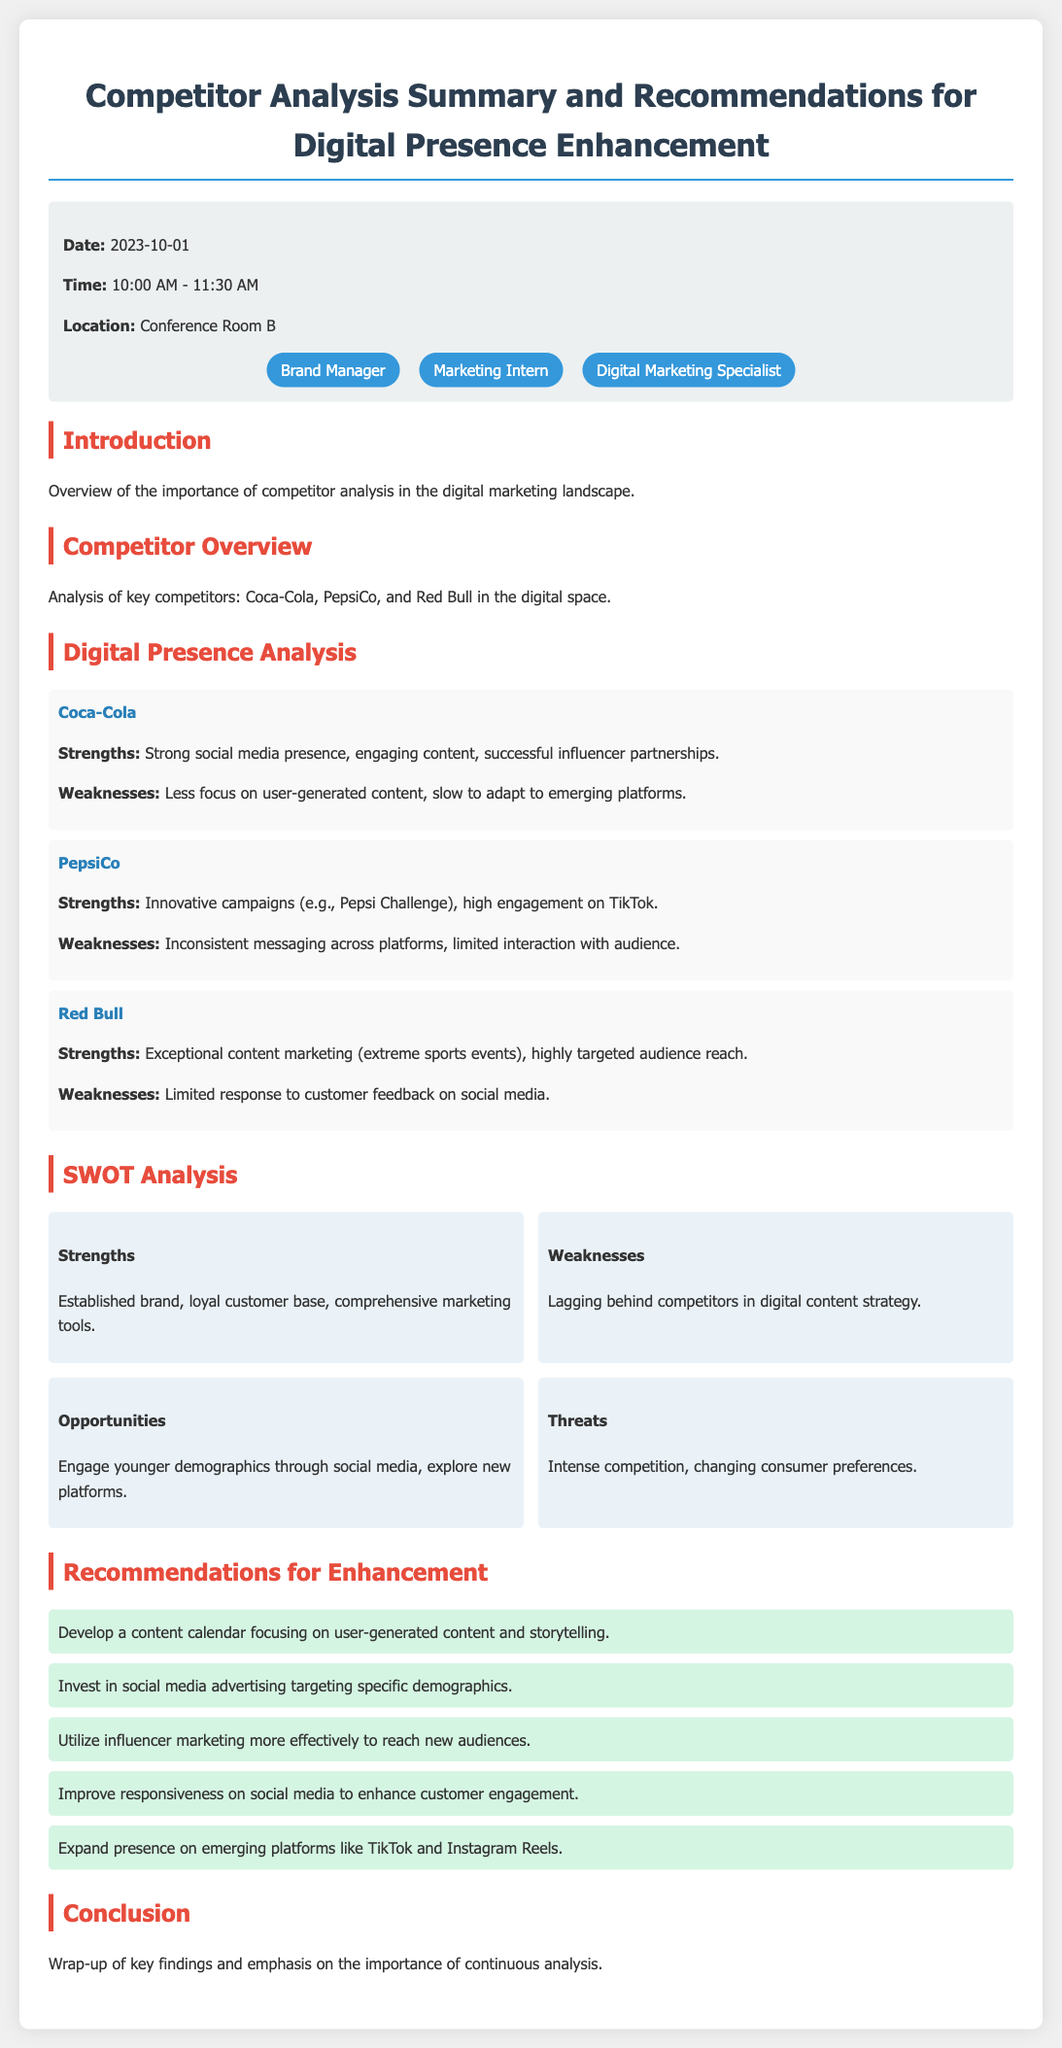What is the date of the meeting? The date of the meeting is indicated in the meeting info section of the document.
Answer: 2023-10-01 Who is mentioned as having a strong social media presence? The document highlights Coca-Cola's strengths, which includes a strong social media presence.
Answer: Coca-Cola What is one of PepsiCo's weaknesses according to the analysis? The analysis notes PepsiCo's inconsistent messaging across platforms as a weakness.
Answer: Inconsistent messaging What type of content should be focused on according to the recommendations? The recommendations suggest developing a content calendar with a focus on user-generated content and storytelling.
Answer: User-generated content How many participants are listed in the meeting info? The participants section shows three individuals participating in the meeting.
Answer: 3 